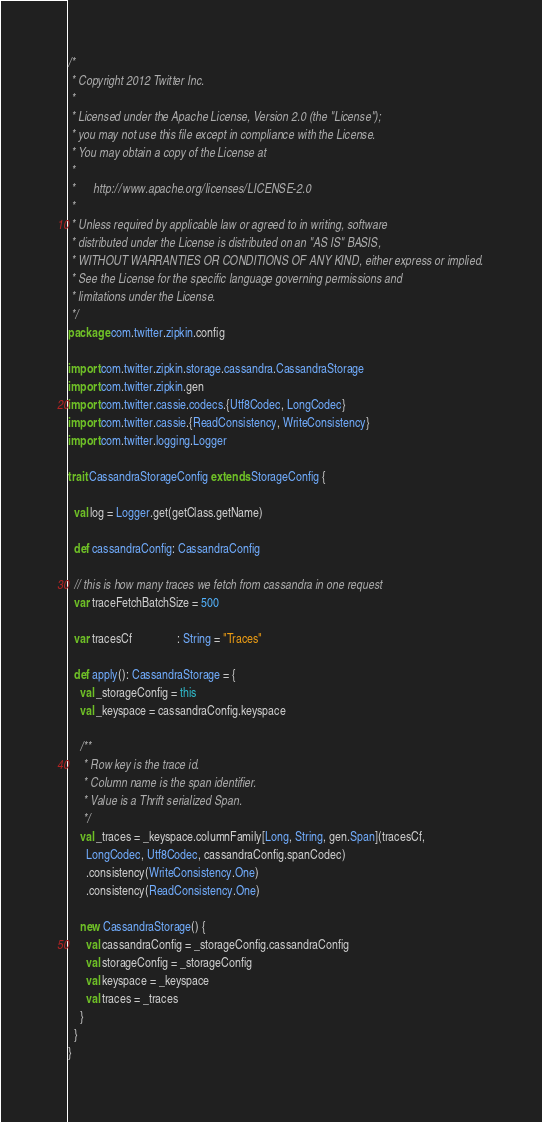<code> <loc_0><loc_0><loc_500><loc_500><_Scala_>/*
 * Copyright 2012 Twitter Inc.
 * 
 * Licensed under the Apache License, Version 2.0 (the "License");
 * you may not use this file except in compliance with the License.
 * You may obtain a copy of the License at
 * 
 *      http://www.apache.org/licenses/LICENSE-2.0
 * 
 * Unless required by applicable law or agreed to in writing, software
 * distributed under the License is distributed on an "AS IS" BASIS,
 * WITHOUT WARRANTIES OR CONDITIONS OF ANY KIND, either express or implied.
 * See the License for the specific language governing permissions and
 * limitations under the License.
 */
package com.twitter.zipkin.config

import com.twitter.zipkin.storage.cassandra.CassandraStorage
import com.twitter.zipkin.gen
import com.twitter.cassie.codecs.{Utf8Codec, LongCodec}
import com.twitter.cassie.{ReadConsistency, WriteConsistency}
import com.twitter.logging.Logger

trait CassandraStorageConfig extends StorageConfig {

  val log = Logger.get(getClass.getName)

  def cassandraConfig: CassandraConfig

  // this is how many traces we fetch from cassandra in one request
  var traceFetchBatchSize = 500

  var tracesCf               : String = "Traces"

  def apply(): CassandraStorage = {
    val _storageConfig = this
    val _keyspace = cassandraConfig.keyspace

    /**
     * Row key is the trace id.
     * Column name is the span identifier.
     * Value is a Thrift serialized Span.
     */
    val _traces = _keyspace.columnFamily[Long, String, gen.Span](tracesCf,
      LongCodec, Utf8Codec, cassandraConfig.spanCodec)
      .consistency(WriteConsistency.One)
      .consistency(ReadConsistency.One)

    new CassandraStorage() {
      val cassandraConfig = _storageConfig.cassandraConfig
      val storageConfig = _storageConfig
      val keyspace = _keyspace
      val traces = _traces
    }
  }
}
</code> 